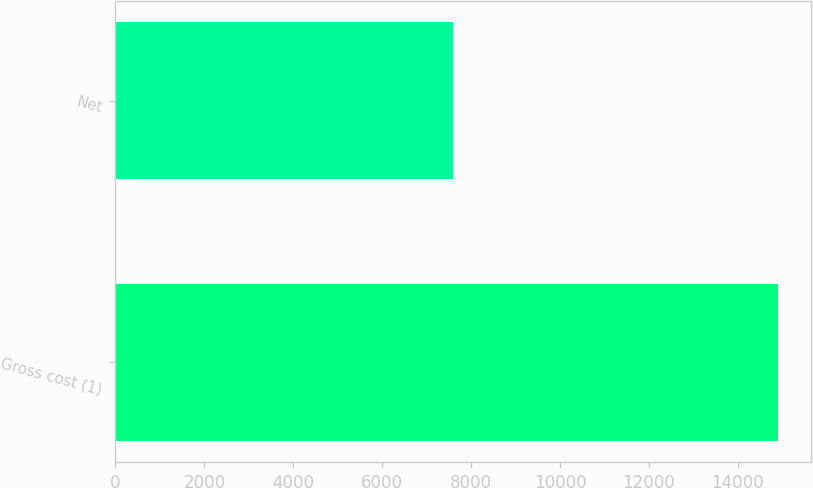<chart> <loc_0><loc_0><loc_500><loc_500><bar_chart><fcel>Gross cost (1)<fcel>Net<nl><fcel>14910<fcel>7595<nl></chart> 